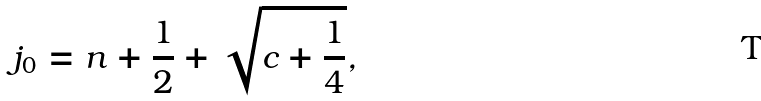<formula> <loc_0><loc_0><loc_500><loc_500>j _ { 0 } = n + \frac { 1 } { 2 } + \sqrt { c + \frac { 1 } { 4 } } ,</formula> 